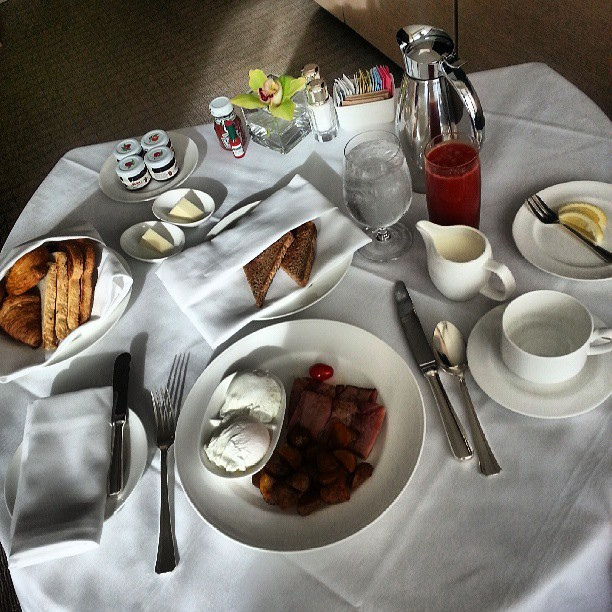<image>What kind of flower is on the table? I am not sure what kind of flower is on the table. It could be a lily, rose, tulip, orchid, petunia, or there might be no flower at all. What kind of flower is on the table? I am not sure what kind of flower is on the table. It can be seen 'lily', 'rose', 'tulip', 'orchid', or 'petunia'. 